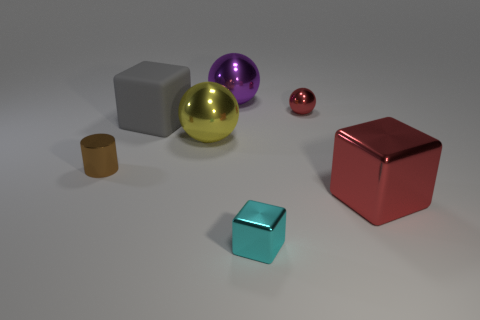Add 3 purple metallic cubes. How many objects exist? 10 Subtract all cylinders. How many objects are left? 6 Subtract 0 brown balls. How many objects are left? 7 Subtract all cyan cubes. Subtract all small cyan shiny blocks. How many objects are left? 5 Add 3 red metallic cubes. How many red metallic cubes are left? 4 Add 1 small yellow rubber blocks. How many small yellow rubber blocks exist? 1 